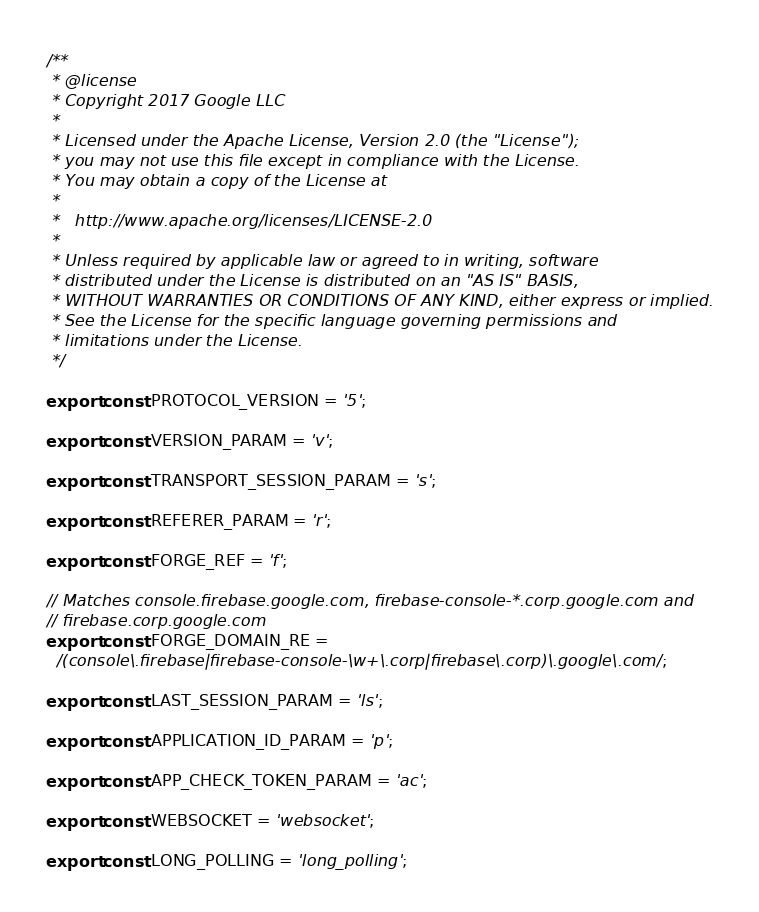<code> <loc_0><loc_0><loc_500><loc_500><_TypeScript_>/**
 * @license
 * Copyright 2017 Google LLC
 *
 * Licensed under the Apache License, Version 2.0 (the "License");
 * you may not use this file except in compliance with the License.
 * You may obtain a copy of the License at
 *
 *   http://www.apache.org/licenses/LICENSE-2.0
 *
 * Unless required by applicable law or agreed to in writing, software
 * distributed under the License is distributed on an "AS IS" BASIS,
 * WITHOUT WARRANTIES OR CONDITIONS OF ANY KIND, either express or implied.
 * See the License for the specific language governing permissions and
 * limitations under the License.
 */

export const PROTOCOL_VERSION = '5';

export const VERSION_PARAM = 'v';

export const TRANSPORT_SESSION_PARAM = 's';

export const REFERER_PARAM = 'r';

export const FORGE_REF = 'f';

// Matches console.firebase.google.com, firebase-console-*.corp.google.com and
// firebase.corp.google.com
export const FORGE_DOMAIN_RE =
  /(console\.firebase|firebase-console-\w+\.corp|firebase\.corp)\.google\.com/;

export const LAST_SESSION_PARAM = 'ls';

export const APPLICATION_ID_PARAM = 'p';

export const APP_CHECK_TOKEN_PARAM = 'ac';

export const WEBSOCKET = 'websocket';

export const LONG_POLLING = 'long_polling';
</code> 